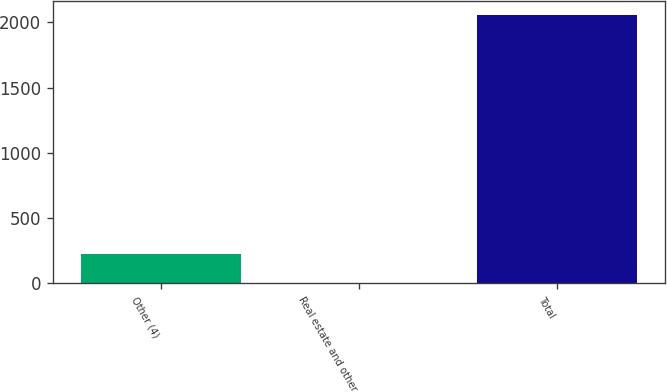Convert chart. <chart><loc_0><loc_0><loc_500><loc_500><bar_chart><fcel>Other (4)<fcel>Real estate and other<fcel>Total<nl><fcel>225<fcel>1<fcel>2060<nl></chart> 